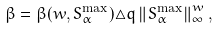<formula> <loc_0><loc_0><loc_500><loc_500>\beta = \beta ( w , S _ { \alpha } ^ { \max } ) \triangle q \left \| S _ { \alpha } ^ { \max } \right \| _ { \infty } ^ { w } ,</formula> 